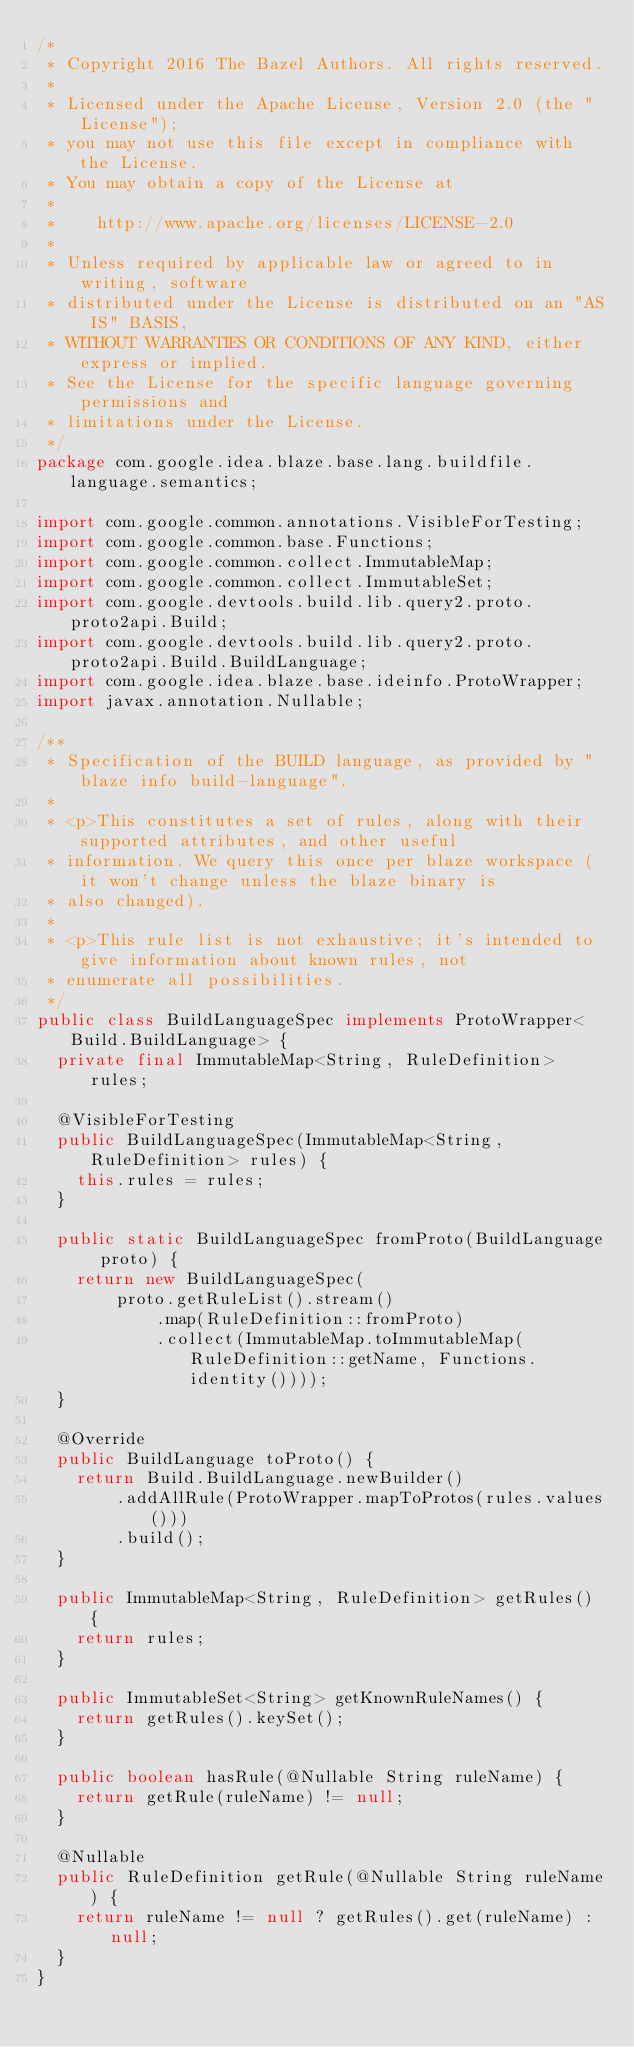<code> <loc_0><loc_0><loc_500><loc_500><_Java_>/*
 * Copyright 2016 The Bazel Authors. All rights reserved.
 *
 * Licensed under the Apache License, Version 2.0 (the "License");
 * you may not use this file except in compliance with the License.
 * You may obtain a copy of the License at
 *
 *    http://www.apache.org/licenses/LICENSE-2.0
 *
 * Unless required by applicable law or agreed to in writing, software
 * distributed under the License is distributed on an "AS IS" BASIS,
 * WITHOUT WARRANTIES OR CONDITIONS OF ANY KIND, either express or implied.
 * See the License for the specific language governing permissions and
 * limitations under the License.
 */
package com.google.idea.blaze.base.lang.buildfile.language.semantics;

import com.google.common.annotations.VisibleForTesting;
import com.google.common.base.Functions;
import com.google.common.collect.ImmutableMap;
import com.google.common.collect.ImmutableSet;
import com.google.devtools.build.lib.query2.proto.proto2api.Build;
import com.google.devtools.build.lib.query2.proto.proto2api.Build.BuildLanguage;
import com.google.idea.blaze.base.ideinfo.ProtoWrapper;
import javax.annotation.Nullable;

/**
 * Specification of the BUILD language, as provided by "blaze info build-language".
 *
 * <p>This constitutes a set of rules, along with their supported attributes, and other useful
 * information. We query this once per blaze workspace (it won't change unless the blaze binary is
 * also changed).
 *
 * <p>This rule list is not exhaustive; it's intended to give information about known rules, not
 * enumerate all possibilities.
 */
public class BuildLanguageSpec implements ProtoWrapper<Build.BuildLanguage> {
  private final ImmutableMap<String, RuleDefinition> rules;

  @VisibleForTesting
  public BuildLanguageSpec(ImmutableMap<String, RuleDefinition> rules) {
    this.rules = rules;
  }

  public static BuildLanguageSpec fromProto(BuildLanguage proto) {
    return new BuildLanguageSpec(
        proto.getRuleList().stream()
            .map(RuleDefinition::fromProto)
            .collect(ImmutableMap.toImmutableMap(RuleDefinition::getName, Functions.identity())));
  }

  @Override
  public BuildLanguage toProto() {
    return Build.BuildLanguage.newBuilder()
        .addAllRule(ProtoWrapper.mapToProtos(rules.values()))
        .build();
  }

  public ImmutableMap<String, RuleDefinition> getRules() {
    return rules;
  }

  public ImmutableSet<String> getKnownRuleNames() {
    return getRules().keySet();
  }

  public boolean hasRule(@Nullable String ruleName) {
    return getRule(ruleName) != null;
  }

  @Nullable
  public RuleDefinition getRule(@Nullable String ruleName) {
    return ruleName != null ? getRules().get(ruleName) : null;
  }
}
</code> 